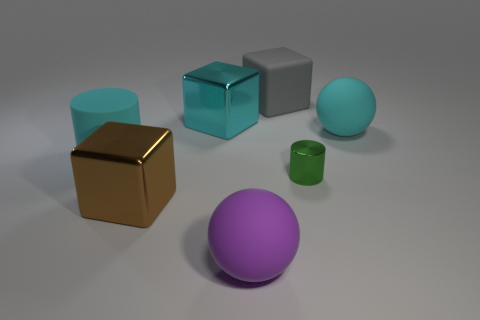Is the number of cyan rubber things in front of the cyan matte cylinder less than the number of matte objects?
Offer a terse response. Yes. Are there any big metallic objects that have the same color as the rubber cylinder?
Your response must be concise. Yes. Do the big cyan shiny thing and the large shiny thing in front of the cyan cylinder have the same shape?
Your answer should be very brief. Yes. Are there any yellow spheres that have the same material as the purple thing?
Offer a terse response. No. There is a cyan matte object that is to the left of the big cyan thing on the right side of the large cyan cube; are there any cubes that are in front of it?
Offer a terse response. Yes. What number of other objects are the same shape as the tiny green shiny thing?
Provide a succinct answer. 1. What is the color of the large metallic thing in front of the cyan thing in front of the cyan matte object that is to the right of the green metal thing?
Provide a short and direct response. Brown. How many big purple matte things are there?
Keep it short and to the point. 1. How many small objects are brown objects or gray rubber objects?
Provide a succinct answer. 0. What shape is the cyan metal thing that is the same size as the gray matte cube?
Give a very brief answer. Cube. 